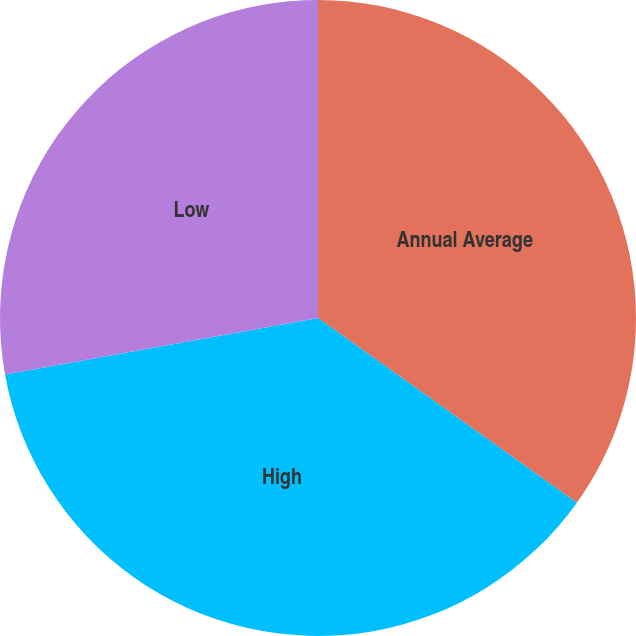Convert chart to OTSL. <chart><loc_0><loc_0><loc_500><loc_500><pie_chart><fcel>Annual Average<fcel>High<fcel>Low<nl><fcel>34.86%<fcel>37.3%<fcel>27.84%<nl></chart> 